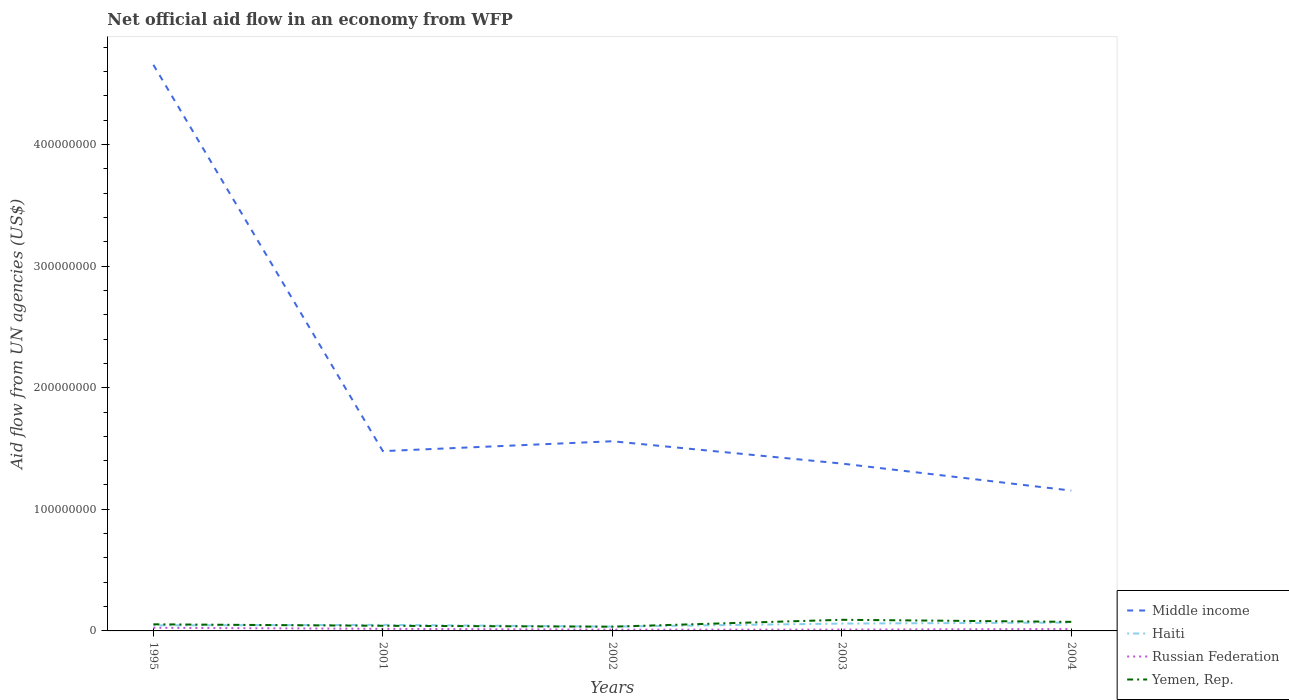How many different coloured lines are there?
Offer a terse response. 4. Across all years, what is the maximum net official aid flow in Haiti?
Your response must be concise. 3.57e+06. What is the total net official aid flow in Russian Federation in the graph?
Provide a succinct answer. 8.50e+05. What is the difference between the highest and the second highest net official aid flow in Middle income?
Provide a short and direct response. 3.50e+08. What is the difference between the highest and the lowest net official aid flow in Yemen, Rep.?
Your answer should be compact. 2. Is the net official aid flow in Yemen, Rep. strictly greater than the net official aid flow in Middle income over the years?
Your answer should be very brief. Yes. Are the values on the major ticks of Y-axis written in scientific E-notation?
Make the answer very short. No. Does the graph contain grids?
Offer a terse response. No. What is the title of the graph?
Make the answer very short. Net official aid flow in an economy from WFP. Does "Cameroon" appear as one of the legend labels in the graph?
Your response must be concise. No. What is the label or title of the Y-axis?
Your answer should be compact. Aid flow from UN agencies (US$). What is the Aid flow from UN agencies (US$) of Middle income in 1995?
Your answer should be very brief. 4.65e+08. What is the Aid flow from UN agencies (US$) in Haiti in 1995?
Give a very brief answer. 4.57e+06. What is the Aid flow from UN agencies (US$) in Russian Federation in 1995?
Provide a succinct answer. 2.58e+06. What is the Aid flow from UN agencies (US$) of Yemen, Rep. in 1995?
Make the answer very short. 5.43e+06. What is the Aid flow from UN agencies (US$) of Middle income in 2001?
Ensure brevity in your answer.  1.48e+08. What is the Aid flow from UN agencies (US$) in Haiti in 2001?
Your answer should be compact. 4.97e+06. What is the Aid flow from UN agencies (US$) in Russian Federation in 2001?
Your response must be concise. 1.73e+06. What is the Aid flow from UN agencies (US$) in Yemen, Rep. in 2001?
Ensure brevity in your answer.  4.22e+06. What is the Aid flow from UN agencies (US$) in Middle income in 2002?
Provide a succinct answer. 1.56e+08. What is the Aid flow from UN agencies (US$) of Haiti in 2002?
Your response must be concise. 3.57e+06. What is the Aid flow from UN agencies (US$) in Russian Federation in 2002?
Your answer should be compact. 1.02e+06. What is the Aid flow from UN agencies (US$) of Yemen, Rep. in 2002?
Keep it short and to the point. 3.49e+06. What is the Aid flow from UN agencies (US$) in Middle income in 2003?
Offer a very short reply. 1.38e+08. What is the Aid flow from UN agencies (US$) in Haiti in 2003?
Your answer should be very brief. 6.04e+06. What is the Aid flow from UN agencies (US$) in Russian Federation in 2003?
Keep it short and to the point. 1.10e+06. What is the Aid flow from UN agencies (US$) of Yemen, Rep. in 2003?
Provide a succinct answer. 9.15e+06. What is the Aid flow from UN agencies (US$) in Middle income in 2004?
Ensure brevity in your answer.  1.15e+08. What is the Aid flow from UN agencies (US$) in Haiti in 2004?
Keep it short and to the point. 6.87e+06. What is the Aid flow from UN agencies (US$) in Russian Federation in 2004?
Your answer should be very brief. 1.55e+06. What is the Aid flow from UN agencies (US$) of Yemen, Rep. in 2004?
Give a very brief answer. 7.45e+06. Across all years, what is the maximum Aid flow from UN agencies (US$) in Middle income?
Your response must be concise. 4.65e+08. Across all years, what is the maximum Aid flow from UN agencies (US$) in Haiti?
Provide a short and direct response. 6.87e+06. Across all years, what is the maximum Aid flow from UN agencies (US$) in Russian Federation?
Your response must be concise. 2.58e+06. Across all years, what is the maximum Aid flow from UN agencies (US$) of Yemen, Rep.?
Ensure brevity in your answer.  9.15e+06. Across all years, what is the minimum Aid flow from UN agencies (US$) of Middle income?
Give a very brief answer. 1.15e+08. Across all years, what is the minimum Aid flow from UN agencies (US$) in Haiti?
Provide a short and direct response. 3.57e+06. Across all years, what is the minimum Aid flow from UN agencies (US$) in Russian Federation?
Provide a short and direct response. 1.02e+06. Across all years, what is the minimum Aid flow from UN agencies (US$) in Yemen, Rep.?
Your answer should be compact. 3.49e+06. What is the total Aid flow from UN agencies (US$) of Middle income in the graph?
Your answer should be compact. 1.02e+09. What is the total Aid flow from UN agencies (US$) in Haiti in the graph?
Give a very brief answer. 2.60e+07. What is the total Aid flow from UN agencies (US$) in Russian Federation in the graph?
Offer a very short reply. 7.98e+06. What is the total Aid flow from UN agencies (US$) of Yemen, Rep. in the graph?
Offer a very short reply. 2.97e+07. What is the difference between the Aid flow from UN agencies (US$) in Middle income in 1995 and that in 2001?
Give a very brief answer. 3.18e+08. What is the difference between the Aid flow from UN agencies (US$) in Haiti in 1995 and that in 2001?
Offer a very short reply. -4.00e+05. What is the difference between the Aid flow from UN agencies (US$) in Russian Federation in 1995 and that in 2001?
Provide a succinct answer. 8.50e+05. What is the difference between the Aid flow from UN agencies (US$) in Yemen, Rep. in 1995 and that in 2001?
Your response must be concise. 1.21e+06. What is the difference between the Aid flow from UN agencies (US$) in Middle income in 1995 and that in 2002?
Provide a short and direct response. 3.10e+08. What is the difference between the Aid flow from UN agencies (US$) in Haiti in 1995 and that in 2002?
Keep it short and to the point. 1.00e+06. What is the difference between the Aid flow from UN agencies (US$) in Russian Federation in 1995 and that in 2002?
Give a very brief answer. 1.56e+06. What is the difference between the Aid flow from UN agencies (US$) of Yemen, Rep. in 1995 and that in 2002?
Ensure brevity in your answer.  1.94e+06. What is the difference between the Aid flow from UN agencies (US$) in Middle income in 1995 and that in 2003?
Make the answer very short. 3.28e+08. What is the difference between the Aid flow from UN agencies (US$) in Haiti in 1995 and that in 2003?
Your response must be concise. -1.47e+06. What is the difference between the Aid flow from UN agencies (US$) in Russian Federation in 1995 and that in 2003?
Provide a short and direct response. 1.48e+06. What is the difference between the Aid flow from UN agencies (US$) of Yemen, Rep. in 1995 and that in 2003?
Your answer should be compact. -3.72e+06. What is the difference between the Aid flow from UN agencies (US$) in Middle income in 1995 and that in 2004?
Offer a terse response. 3.50e+08. What is the difference between the Aid flow from UN agencies (US$) in Haiti in 1995 and that in 2004?
Offer a terse response. -2.30e+06. What is the difference between the Aid flow from UN agencies (US$) of Russian Federation in 1995 and that in 2004?
Ensure brevity in your answer.  1.03e+06. What is the difference between the Aid flow from UN agencies (US$) in Yemen, Rep. in 1995 and that in 2004?
Make the answer very short. -2.02e+06. What is the difference between the Aid flow from UN agencies (US$) in Middle income in 2001 and that in 2002?
Keep it short and to the point. -8.12e+06. What is the difference between the Aid flow from UN agencies (US$) of Haiti in 2001 and that in 2002?
Ensure brevity in your answer.  1.40e+06. What is the difference between the Aid flow from UN agencies (US$) of Russian Federation in 2001 and that in 2002?
Make the answer very short. 7.10e+05. What is the difference between the Aid flow from UN agencies (US$) of Yemen, Rep. in 2001 and that in 2002?
Your answer should be compact. 7.30e+05. What is the difference between the Aid flow from UN agencies (US$) of Middle income in 2001 and that in 2003?
Offer a terse response. 1.02e+07. What is the difference between the Aid flow from UN agencies (US$) of Haiti in 2001 and that in 2003?
Your answer should be compact. -1.07e+06. What is the difference between the Aid flow from UN agencies (US$) in Russian Federation in 2001 and that in 2003?
Ensure brevity in your answer.  6.30e+05. What is the difference between the Aid flow from UN agencies (US$) of Yemen, Rep. in 2001 and that in 2003?
Offer a terse response. -4.93e+06. What is the difference between the Aid flow from UN agencies (US$) in Middle income in 2001 and that in 2004?
Make the answer very short. 3.24e+07. What is the difference between the Aid flow from UN agencies (US$) of Haiti in 2001 and that in 2004?
Offer a terse response. -1.90e+06. What is the difference between the Aid flow from UN agencies (US$) in Russian Federation in 2001 and that in 2004?
Provide a succinct answer. 1.80e+05. What is the difference between the Aid flow from UN agencies (US$) of Yemen, Rep. in 2001 and that in 2004?
Provide a succinct answer. -3.23e+06. What is the difference between the Aid flow from UN agencies (US$) of Middle income in 2002 and that in 2003?
Provide a succinct answer. 1.84e+07. What is the difference between the Aid flow from UN agencies (US$) of Haiti in 2002 and that in 2003?
Your response must be concise. -2.47e+06. What is the difference between the Aid flow from UN agencies (US$) of Russian Federation in 2002 and that in 2003?
Provide a short and direct response. -8.00e+04. What is the difference between the Aid flow from UN agencies (US$) of Yemen, Rep. in 2002 and that in 2003?
Your answer should be very brief. -5.66e+06. What is the difference between the Aid flow from UN agencies (US$) in Middle income in 2002 and that in 2004?
Your answer should be very brief. 4.06e+07. What is the difference between the Aid flow from UN agencies (US$) of Haiti in 2002 and that in 2004?
Offer a terse response. -3.30e+06. What is the difference between the Aid flow from UN agencies (US$) of Russian Federation in 2002 and that in 2004?
Offer a terse response. -5.30e+05. What is the difference between the Aid flow from UN agencies (US$) of Yemen, Rep. in 2002 and that in 2004?
Provide a succinct answer. -3.96e+06. What is the difference between the Aid flow from UN agencies (US$) in Middle income in 2003 and that in 2004?
Your answer should be very brief. 2.22e+07. What is the difference between the Aid flow from UN agencies (US$) in Haiti in 2003 and that in 2004?
Provide a succinct answer. -8.30e+05. What is the difference between the Aid flow from UN agencies (US$) in Russian Federation in 2003 and that in 2004?
Make the answer very short. -4.50e+05. What is the difference between the Aid flow from UN agencies (US$) in Yemen, Rep. in 2003 and that in 2004?
Provide a succinct answer. 1.70e+06. What is the difference between the Aid flow from UN agencies (US$) in Middle income in 1995 and the Aid flow from UN agencies (US$) in Haiti in 2001?
Your answer should be compact. 4.61e+08. What is the difference between the Aid flow from UN agencies (US$) of Middle income in 1995 and the Aid flow from UN agencies (US$) of Russian Federation in 2001?
Offer a very short reply. 4.64e+08. What is the difference between the Aid flow from UN agencies (US$) of Middle income in 1995 and the Aid flow from UN agencies (US$) of Yemen, Rep. in 2001?
Offer a very short reply. 4.61e+08. What is the difference between the Aid flow from UN agencies (US$) in Haiti in 1995 and the Aid flow from UN agencies (US$) in Russian Federation in 2001?
Offer a very short reply. 2.84e+06. What is the difference between the Aid flow from UN agencies (US$) in Haiti in 1995 and the Aid flow from UN agencies (US$) in Yemen, Rep. in 2001?
Provide a succinct answer. 3.50e+05. What is the difference between the Aid flow from UN agencies (US$) in Russian Federation in 1995 and the Aid flow from UN agencies (US$) in Yemen, Rep. in 2001?
Give a very brief answer. -1.64e+06. What is the difference between the Aid flow from UN agencies (US$) of Middle income in 1995 and the Aid flow from UN agencies (US$) of Haiti in 2002?
Your response must be concise. 4.62e+08. What is the difference between the Aid flow from UN agencies (US$) of Middle income in 1995 and the Aid flow from UN agencies (US$) of Russian Federation in 2002?
Your answer should be very brief. 4.64e+08. What is the difference between the Aid flow from UN agencies (US$) of Middle income in 1995 and the Aid flow from UN agencies (US$) of Yemen, Rep. in 2002?
Keep it short and to the point. 4.62e+08. What is the difference between the Aid flow from UN agencies (US$) of Haiti in 1995 and the Aid flow from UN agencies (US$) of Russian Federation in 2002?
Ensure brevity in your answer.  3.55e+06. What is the difference between the Aid flow from UN agencies (US$) in Haiti in 1995 and the Aid flow from UN agencies (US$) in Yemen, Rep. in 2002?
Your answer should be very brief. 1.08e+06. What is the difference between the Aid flow from UN agencies (US$) of Russian Federation in 1995 and the Aid flow from UN agencies (US$) of Yemen, Rep. in 2002?
Keep it short and to the point. -9.10e+05. What is the difference between the Aid flow from UN agencies (US$) of Middle income in 1995 and the Aid flow from UN agencies (US$) of Haiti in 2003?
Your answer should be compact. 4.59e+08. What is the difference between the Aid flow from UN agencies (US$) in Middle income in 1995 and the Aid flow from UN agencies (US$) in Russian Federation in 2003?
Give a very brief answer. 4.64e+08. What is the difference between the Aid flow from UN agencies (US$) in Middle income in 1995 and the Aid flow from UN agencies (US$) in Yemen, Rep. in 2003?
Keep it short and to the point. 4.56e+08. What is the difference between the Aid flow from UN agencies (US$) in Haiti in 1995 and the Aid flow from UN agencies (US$) in Russian Federation in 2003?
Provide a short and direct response. 3.47e+06. What is the difference between the Aid flow from UN agencies (US$) in Haiti in 1995 and the Aid flow from UN agencies (US$) in Yemen, Rep. in 2003?
Provide a short and direct response. -4.58e+06. What is the difference between the Aid flow from UN agencies (US$) of Russian Federation in 1995 and the Aid flow from UN agencies (US$) of Yemen, Rep. in 2003?
Give a very brief answer. -6.57e+06. What is the difference between the Aid flow from UN agencies (US$) of Middle income in 1995 and the Aid flow from UN agencies (US$) of Haiti in 2004?
Provide a succinct answer. 4.59e+08. What is the difference between the Aid flow from UN agencies (US$) in Middle income in 1995 and the Aid flow from UN agencies (US$) in Russian Federation in 2004?
Make the answer very short. 4.64e+08. What is the difference between the Aid flow from UN agencies (US$) of Middle income in 1995 and the Aid flow from UN agencies (US$) of Yemen, Rep. in 2004?
Keep it short and to the point. 4.58e+08. What is the difference between the Aid flow from UN agencies (US$) of Haiti in 1995 and the Aid flow from UN agencies (US$) of Russian Federation in 2004?
Keep it short and to the point. 3.02e+06. What is the difference between the Aid flow from UN agencies (US$) in Haiti in 1995 and the Aid flow from UN agencies (US$) in Yemen, Rep. in 2004?
Keep it short and to the point. -2.88e+06. What is the difference between the Aid flow from UN agencies (US$) of Russian Federation in 1995 and the Aid flow from UN agencies (US$) of Yemen, Rep. in 2004?
Keep it short and to the point. -4.87e+06. What is the difference between the Aid flow from UN agencies (US$) of Middle income in 2001 and the Aid flow from UN agencies (US$) of Haiti in 2002?
Give a very brief answer. 1.44e+08. What is the difference between the Aid flow from UN agencies (US$) in Middle income in 2001 and the Aid flow from UN agencies (US$) in Russian Federation in 2002?
Provide a succinct answer. 1.47e+08. What is the difference between the Aid flow from UN agencies (US$) in Middle income in 2001 and the Aid flow from UN agencies (US$) in Yemen, Rep. in 2002?
Ensure brevity in your answer.  1.44e+08. What is the difference between the Aid flow from UN agencies (US$) of Haiti in 2001 and the Aid flow from UN agencies (US$) of Russian Federation in 2002?
Provide a succinct answer. 3.95e+06. What is the difference between the Aid flow from UN agencies (US$) in Haiti in 2001 and the Aid flow from UN agencies (US$) in Yemen, Rep. in 2002?
Keep it short and to the point. 1.48e+06. What is the difference between the Aid flow from UN agencies (US$) of Russian Federation in 2001 and the Aid flow from UN agencies (US$) of Yemen, Rep. in 2002?
Provide a succinct answer. -1.76e+06. What is the difference between the Aid flow from UN agencies (US$) of Middle income in 2001 and the Aid flow from UN agencies (US$) of Haiti in 2003?
Give a very brief answer. 1.42e+08. What is the difference between the Aid flow from UN agencies (US$) of Middle income in 2001 and the Aid flow from UN agencies (US$) of Russian Federation in 2003?
Keep it short and to the point. 1.47e+08. What is the difference between the Aid flow from UN agencies (US$) of Middle income in 2001 and the Aid flow from UN agencies (US$) of Yemen, Rep. in 2003?
Offer a terse response. 1.39e+08. What is the difference between the Aid flow from UN agencies (US$) in Haiti in 2001 and the Aid flow from UN agencies (US$) in Russian Federation in 2003?
Provide a short and direct response. 3.87e+06. What is the difference between the Aid flow from UN agencies (US$) in Haiti in 2001 and the Aid flow from UN agencies (US$) in Yemen, Rep. in 2003?
Provide a succinct answer. -4.18e+06. What is the difference between the Aid flow from UN agencies (US$) in Russian Federation in 2001 and the Aid flow from UN agencies (US$) in Yemen, Rep. in 2003?
Offer a very short reply. -7.42e+06. What is the difference between the Aid flow from UN agencies (US$) in Middle income in 2001 and the Aid flow from UN agencies (US$) in Haiti in 2004?
Give a very brief answer. 1.41e+08. What is the difference between the Aid flow from UN agencies (US$) in Middle income in 2001 and the Aid flow from UN agencies (US$) in Russian Federation in 2004?
Make the answer very short. 1.46e+08. What is the difference between the Aid flow from UN agencies (US$) in Middle income in 2001 and the Aid flow from UN agencies (US$) in Yemen, Rep. in 2004?
Make the answer very short. 1.40e+08. What is the difference between the Aid flow from UN agencies (US$) of Haiti in 2001 and the Aid flow from UN agencies (US$) of Russian Federation in 2004?
Offer a terse response. 3.42e+06. What is the difference between the Aid flow from UN agencies (US$) of Haiti in 2001 and the Aid flow from UN agencies (US$) of Yemen, Rep. in 2004?
Your answer should be compact. -2.48e+06. What is the difference between the Aid flow from UN agencies (US$) of Russian Federation in 2001 and the Aid flow from UN agencies (US$) of Yemen, Rep. in 2004?
Offer a terse response. -5.72e+06. What is the difference between the Aid flow from UN agencies (US$) of Middle income in 2002 and the Aid flow from UN agencies (US$) of Haiti in 2003?
Provide a short and direct response. 1.50e+08. What is the difference between the Aid flow from UN agencies (US$) in Middle income in 2002 and the Aid flow from UN agencies (US$) in Russian Federation in 2003?
Ensure brevity in your answer.  1.55e+08. What is the difference between the Aid flow from UN agencies (US$) in Middle income in 2002 and the Aid flow from UN agencies (US$) in Yemen, Rep. in 2003?
Give a very brief answer. 1.47e+08. What is the difference between the Aid flow from UN agencies (US$) of Haiti in 2002 and the Aid flow from UN agencies (US$) of Russian Federation in 2003?
Provide a short and direct response. 2.47e+06. What is the difference between the Aid flow from UN agencies (US$) in Haiti in 2002 and the Aid flow from UN agencies (US$) in Yemen, Rep. in 2003?
Provide a short and direct response. -5.58e+06. What is the difference between the Aid flow from UN agencies (US$) in Russian Federation in 2002 and the Aid flow from UN agencies (US$) in Yemen, Rep. in 2003?
Your answer should be very brief. -8.13e+06. What is the difference between the Aid flow from UN agencies (US$) in Middle income in 2002 and the Aid flow from UN agencies (US$) in Haiti in 2004?
Provide a succinct answer. 1.49e+08. What is the difference between the Aid flow from UN agencies (US$) in Middle income in 2002 and the Aid flow from UN agencies (US$) in Russian Federation in 2004?
Provide a short and direct response. 1.54e+08. What is the difference between the Aid flow from UN agencies (US$) in Middle income in 2002 and the Aid flow from UN agencies (US$) in Yemen, Rep. in 2004?
Provide a succinct answer. 1.48e+08. What is the difference between the Aid flow from UN agencies (US$) in Haiti in 2002 and the Aid flow from UN agencies (US$) in Russian Federation in 2004?
Offer a terse response. 2.02e+06. What is the difference between the Aid flow from UN agencies (US$) of Haiti in 2002 and the Aid flow from UN agencies (US$) of Yemen, Rep. in 2004?
Ensure brevity in your answer.  -3.88e+06. What is the difference between the Aid flow from UN agencies (US$) in Russian Federation in 2002 and the Aid flow from UN agencies (US$) in Yemen, Rep. in 2004?
Provide a short and direct response. -6.43e+06. What is the difference between the Aid flow from UN agencies (US$) of Middle income in 2003 and the Aid flow from UN agencies (US$) of Haiti in 2004?
Provide a short and direct response. 1.31e+08. What is the difference between the Aid flow from UN agencies (US$) in Middle income in 2003 and the Aid flow from UN agencies (US$) in Russian Federation in 2004?
Offer a very short reply. 1.36e+08. What is the difference between the Aid flow from UN agencies (US$) of Middle income in 2003 and the Aid flow from UN agencies (US$) of Yemen, Rep. in 2004?
Give a very brief answer. 1.30e+08. What is the difference between the Aid flow from UN agencies (US$) of Haiti in 2003 and the Aid flow from UN agencies (US$) of Russian Federation in 2004?
Give a very brief answer. 4.49e+06. What is the difference between the Aid flow from UN agencies (US$) of Haiti in 2003 and the Aid flow from UN agencies (US$) of Yemen, Rep. in 2004?
Make the answer very short. -1.41e+06. What is the difference between the Aid flow from UN agencies (US$) of Russian Federation in 2003 and the Aid flow from UN agencies (US$) of Yemen, Rep. in 2004?
Keep it short and to the point. -6.35e+06. What is the average Aid flow from UN agencies (US$) in Middle income per year?
Ensure brevity in your answer.  2.04e+08. What is the average Aid flow from UN agencies (US$) in Haiti per year?
Ensure brevity in your answer.  5.20e+06. What is the average Aid flow from UN agencies (US$) of Russian Federation per year?
Offer a very short reply. 1.60e+06. What is the average Aid flow from UN agencies (US$) of Yemen, Rep. per year?
Your answer should be very brief. 5.95e+06. In the year 1995, what is the difference between the Aid flow from UN agencies (US$) of Middle income and Aid flow from UN agencies (US$) of Haiti?
Your answer should be very brief. 4.61e+08. In the year 1995, what is the difference between the Aid flow from UN agencies (US$) of Middle income and Aid flow from UN agencies (US$) of Russian Federation?
Offer a terse response. 4.63e+08. In the year 1995, what is the difference between the Aid flow from UN agencies (US$) of Middle income and Aid flow from UN agencies (US$) of Yemen, Rep.?
Your answer should be very brief. 4.60e+08. In the year 1995, what is the difference between the Aid flow from UN agencies (US$) of Haiti and Aid flow from UN agencies (US$) of Russian Federation?
Your answer should be compact. 1.99e+06. In the year 1995, what is the difference between the Aid flow from UN agencies (US$) in Haiti and Aid flow from UN agencies (US$) in Yemen, Rep.?
Keep it short and to the point. -8.60e+05. In the year 1995, what is the difference between the Aid flow from UN agencies (US$) in Russian Federation and Aid flow from UN agencies (US$) in Yemen, Rep.?
Offer a terse response. -2.85e+06. In the year 2001, what is the difference between the Aid flow from UN agencies (US$) in Middle income and Aid flow from UN agencies (US$) in Haiti?
Give a very brief answer. 1.43e+08. In the year 2001, what is the difference between the Aid flow from UN agencies (US$) in Middle income and Aid flow from UN agencies (US$) in Russian Federation?
Your response must be concise. 1.46e+08. In the year 2001, what is the difference between the Aid flow from UN agencies (US$) of Middle income and Aid flow from UN agencies (US$) of Yemen, Rep.?
Provide a short and direct response. 1.44e+08. In the year 2001, what is the difference between the Aid flow from UN agencies (US$) of Haiti and Aid flow from UN agencies (US$) of Russian Federation?
Give a very brief answer. 3.24e+06. In the year 2001, what is the difference between the Aid flow from UN agencies (US$) of Haiti and Aid flow from UN agencies (US$) of Yemen, Rep.?
Provide a short and direct response. 7.50e+05. In the year 2001, what is the difference between the Aid flow from UN agencies (US$) of Russian Federation and Aid flow from UN agencies (US$) of Yemen, Rep.?
Ensure brevity in your answer.  -2.49e+06. In the year 2002, what is the difference between the Aid flow from UN agencies (US$) of Middle income and Aid flow from UN agencies (US$) of Haiti?
Offer a very short reply. 1.52e+08. In the year 2002, what is the difference between the Aid flow from UN agencies (US$) of Middle income and Aid flow from UN agencies (US$) of Russian Federation?
Your answer should be very brief. 1.55e+08. In the year 2002, what is the difference between the Aid flow from UN agencies (US$) in Middle income and Aid flow from UN agencies (US$) in Yemen, Rep.?
Keep it short and to the point. 1.52e+08. In the year 2002, what is the difference between the Aid flow from UN agencies (US$) of Haiti and Aid flow from UN agencies (US$) of Russian Federation?
Provide a short and direct response. 2.55e+06. In the year 2002, what is the difference between the Aid flow from UN agencies (US$) of Russian Federation and Aid flow from UN agencies (US$) of Yemen, Rep.?
Your response must be concise. -2.47e+06. In the year 2003, what is the difference between the Aid flow from UN agencies (US$) of Middle income and Aid flow from UN agencies (US$) of Haiti?
Your response must be concise. 1.32e+08. In the year 2003, what is the difference between the Aid flow from UN agencies (US$) in Middle income and Aid flow from UN agencies (US$) in Russian Federation?
Provide a short and direct response. 1.36e+08. In the year 2003, what is the difference between the Aid flow from UN agencies (US$) in Middle income and Aid flow from UN agencies (US$) in Yemen, Rep.?
Provide a succinct answer. 1.28e+08. In the year 2003, what is the difference between the Aid flow from UN agencies (US$) of Haiti and Aid flow from UN agencies (US$) of Russian Federation?
Provide a short and direct response. 4.94e+06. In the year 2003, what is the difference between the Aid flow from UN agencies (US$) in Haiti and Aid flow from UN agencies (US$) in Yemen, Rep.?
Provide a short and direct response. -3.11e+06. In the year 2003, what is the difference between the Aid flow from UN agencies (US$) of Russian Federation and Aid flow from UN agencies (US$) of Yemen, Rep.?
Provide a short and direct response. -8.05e+06. In the year 2004, what is the difference between the Aid flow from UN agencies (US$) in Middle income and Aid flow from UN agencies (US$) in Haiti?
Offer a very short reply. 1.09e+08. In the year 2004, what is the difference between the Aid flow from UN agencies (US$) of Middle income and Aid flow from UN agencies (US$) of Russian Federation?
Your answer should be compact. 1.14e+08. In the year 2004, what is the difference between the Aid flow from UN agencies (US$) of Middle income and Aid flow from UN agencies (US$) of Yemen, Rep.?
Give a very brief answer. 1.08e+08. In the year 2004, what is the difference between the Aid flow from UN agencies (US$) of Haiti and Aid flow from UN agencies (US$) of Russian Federation?
Your answer should be very brief. 5.32e+06. In the year 2004, what is the difference between the Aid flow from UN agencies (US$) in Haiti and Aid flow from UN agencies (US$) in Yemen, Rep.?
Give a very brief answer. -5.80e+05. In the year 2004, what is the difference between the Aid flow from UN agencies (US$) in Russian Federation and Aid flow from UN agencies (US$) in Yemen, Rep.?
Ensure brevity in your answer.  -5.90e+06. What is the ratio of the Aid flow from UN agencies (US$) of Middle income in 1995 to that in 2001?
Ensure brevity in your answer.  3.15. What is the ratio of the Aid flow from UN agencies (US$) in Haiti in 1995 to that in 2001?
Offer a very short reply. 0.92. What is the ratio of the Aid flow from UN agencies (US$) in Russian Federation in 1995 to that in 2001?
Ensure brevity in your answer.  1.49. What is the ratio of the Aid flow from UN agencies (US$) in Yemen, Rep. in 1995 to that in 2001?
Offer a terse response. 1.29. What is the ratio of the Aid flow from UN agencies (US$) in Middle income in 1995 to that in 2002?
Give a very brief answer. 2.98. What is the ratio of the Aid flow from UN agencies (US$) in Haiti in 1995 to that in 2002?
Make the answer very short. 1.28. What is the ratio of the Aid flow from UN agencies (US$) of Russian Federation in 1995 to that in 2002?
Your response must be concise. 2.53. What is the ratio of the Aid flow from UN agencies (US$) in Yemen, Rep. in 1995 to that in 2002?
Keep it short and to the point. 1.56. What is the ratio of the Aid flow from UN agencies (US$) of Middle income in 1995 to that in 2003?
Provide a succinct answer. 3.38. What is the ratio of the Aid flow from UN agencies (US$) of Haiti in 1995 to that in 2003?
Offer a very short reply. 0.76. What is the ratio of the Aid flow from UN agencies (US$) in Russian Federation in 1995 to that in 2003?
Provide a succinct answer. 2.35. What is the ratio of the Aid flow from UN agencies (US$) of Yemen, Rep. in 1995 to that in 2003?
Offer a very short reply. 0.59. What is the ratio of the Aid flow from UN agencies (US$) in Middle income in 1995 to that in 2004?
Provide a succinct answer. 4.03. What is the ratio of the Aid flow from UN agencies (US$) of Haiti in 1995 to that in 2004?
Provide a short and direct response. 0.67. What is the ratio of the Aid flow from UN agencies (US$) of Russian Federation in 1995 to that in 2004?
Your answer should be compact. 1.66. What is the ratio of the Aid flow from UN agencies (US$) in Yemen, Rep. in 1995 to that in 2004?
Your answer should be very brief. 0.73. What is the ratio of the Aid flow from UN agencies (US$) in Middle income in 2001 to that in 2002?
Offer a terse response. 0.95. What is the ratio of the Aid flow from UN agencies (US$) in Haiti in 2001 to that in 2002?
Keep it short and to the point. 1.39. What is the ratio of the Aid flow from UN agencies (US$) in Russian Federation in 2001 to that in 2002?
Your answer should be compact. 1.7. What is the ratio of the Aid flow from UN agencies (US$) of Yemen, Rep. in 2001 to that in 2002?
Keep it short and to the point. 1.21. What is the ratio of the Aid flow from UN agencies (US$) in Middle income in 2001 to that in 2003?
Your response must be concise. 1.07. What is the ratio of the Aid flow from UN agencies (US$) in Haiti in 2001 to that in 2003?
Your answer should be compact. 0.82. What is the ratio of the Aid flow from UN agencies (US$) in Russian Federation in 2001 to that in 2003?
Provide a succinct answer. 1.57. What is the ratio of the Aid flow from UN agencies (US$) in Yemen, Rep. in 2001 to that in 2003?
Your answer should be compact. 0.46. What is the ratio of the Aid flow from UN agencies (US$) of Middle income in 2001 to that in 2004?
Your response must be concise. 1.28. What is the ratio of the Aid flow from UN agencies (US$) of Haiti in 2001 to that in 2004?
Your answer should be very brief. 0.72. What is the ratio of the Aid flow from UN agencies (US$) in Russian Federation in 2001 to that in 2004?
Offer a terse response. 1.12. What is the ratio of the Aid flow from UN agencies (US$) of Yemen, Rep. in 2001 to that in 2004?
Your response must be concise. 0.57. What is the ratio of the Aid flow from UN agencies (US$) in Middle income in 2002 to that in 2003?
Offer a terse response. 1.13. What is the ratio of the Aid flow from UN agencies (US$) in Haiti in 2002 to that in 2003?
Ensure brevity in your answer.  0.59. What is the ratio of the Aid flow from UN agencies (US$) of Russian Federation in 2002 to that in 2003?
Provide a succinct answer. 0.93. What is the ratio of the Aid flow from UN agencies (US$) of Yemen, Rep. in 2002 to that in 2003?
Offer a terse response. 0.38. What is the ratio of the Aid flow from UN agencies (US$) in Middle income in 2002 to that in 2004?
Offer a terse response. 1.35. What is the ratio of the Aid flow from UN agencies (US$) in Haiti in 2002 to that in 2004?
Your answer should be compact. 0.52. What is the ratio of the Aid flow from UN agencies (US$) of Russian Federation in 2002 to that in 2004?
Provide a succinct answer. 0.66. What is the ratio of the Aid flow from UN agencies (US$) in Yemen, Rep. in 2002 to that in 2004?
Provide a succinct answer. 0.47. What is the ratio of the Aid flow from UN agencies (US$) of Middle income in 2003 to that in 2004?
Your answer should be very brief. 1.19. What is the ratio of the Aid flow from UN agencies (US$) in Haiti in 2003 to that in 2004?
Ensure brevity in your answer.  0.88. What is the ratio of the Aid flow from UN agencies (US$) of Russian Federation in 2003 to that in 2004?
Give a very brief answer. 0.71. What is the ratio of the Aid flow from UN agencies (US$) of Yemen, Rep. in 2003 to that in 2004?
Give a very brief answer. 1.23. What is the difference between the highest and the second highest Aid flow from UN agencies (US$) in Middle income?
Offer a terse response. 3.10e+08. What is the difference between the highest and the second highest Aid flow from UN agencies (US$) of Haiti?
Ensure brevity in your answer.  8.30e+05. What is the difference between the highest and the second highest Aid flow from UN agencies (US$) of Russian Federation?
Your answer should be compact. 8.50e+05. What is the difference between the highest and the second highest Aid flow from UN agencies (US$) of Yemen, Rep.?
Provide a short and direct response. 1.70e+06. What is the difference between the highest and the lowest Aid flow from UN agencies (US$) of Middle income?
Give a very brief answer. 3.50e+08. What is the difference between the highest and the lowest Aid flow from UN agencies (US$) in Haiti?
Provide a succinct answer. 3.30e+06. What is the difference between the highest and the lowest Aid flow from UN agencies (US$) of Russian Federation?
Provide a short and direct response. 1.56e+06. What is the difference between the highest and the lowest Aid flow from UN agencies (US$) of Yemen, Rep.?
Offer a very short reply. 5.66e+06. 